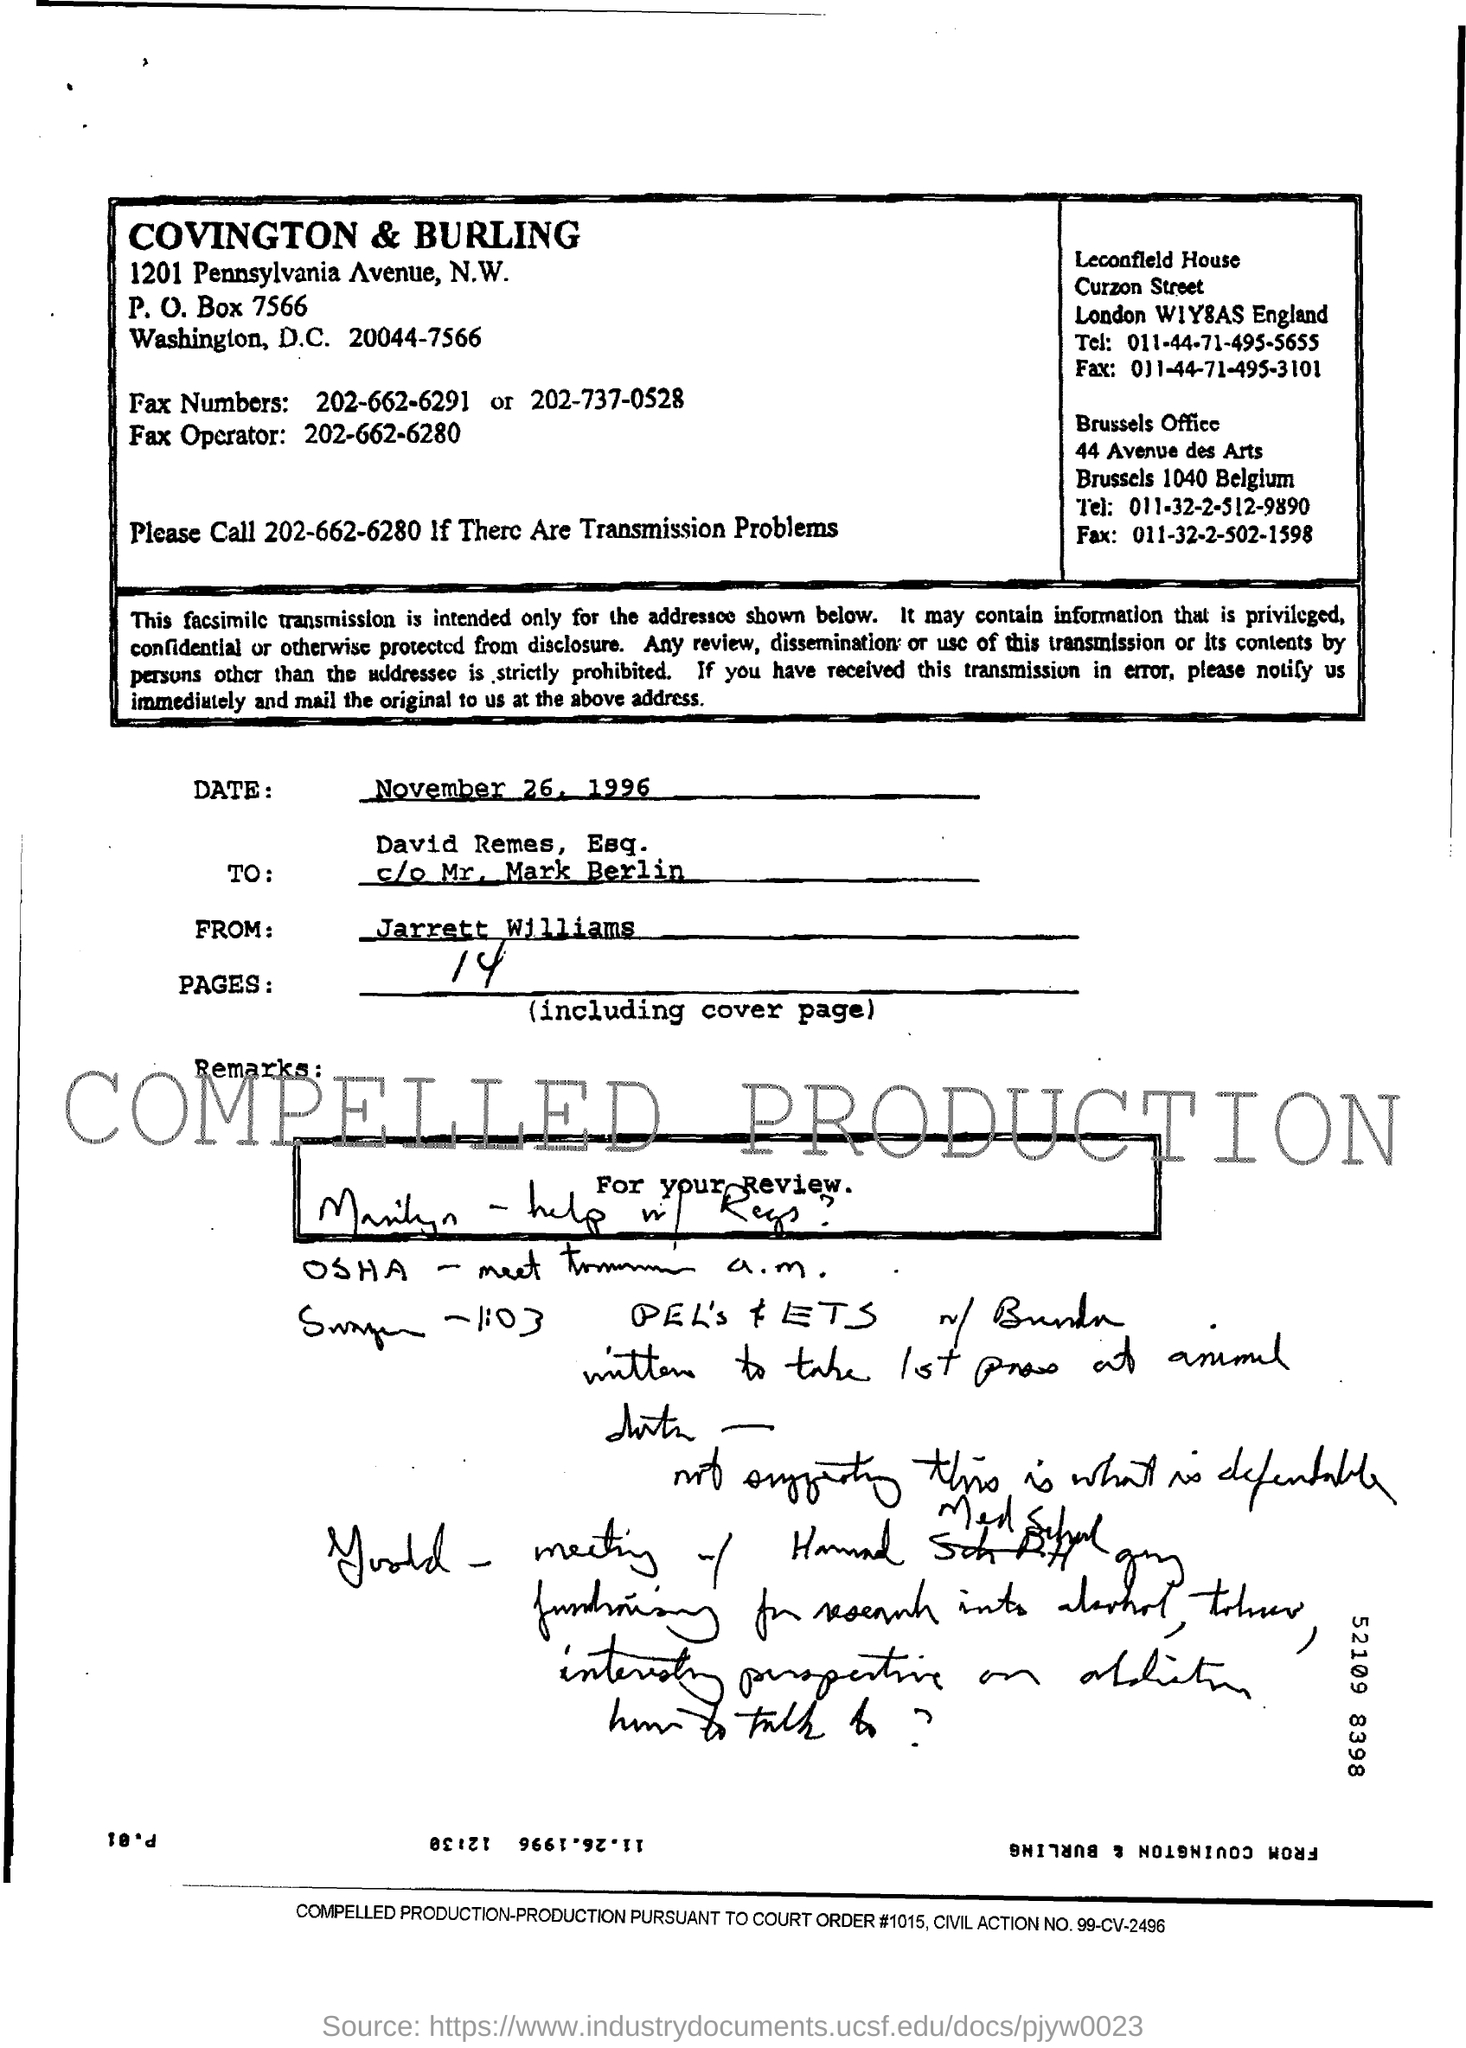Mention a couple of crucial points in this snapshot. The number that must be called for transmission problems is 202-662-6280. There are 14 pages in total. The sender of this fax is Jarrett Williams. What is the court order number? It is 1015. The P.O. box number of Covington & Burling is 7566... 